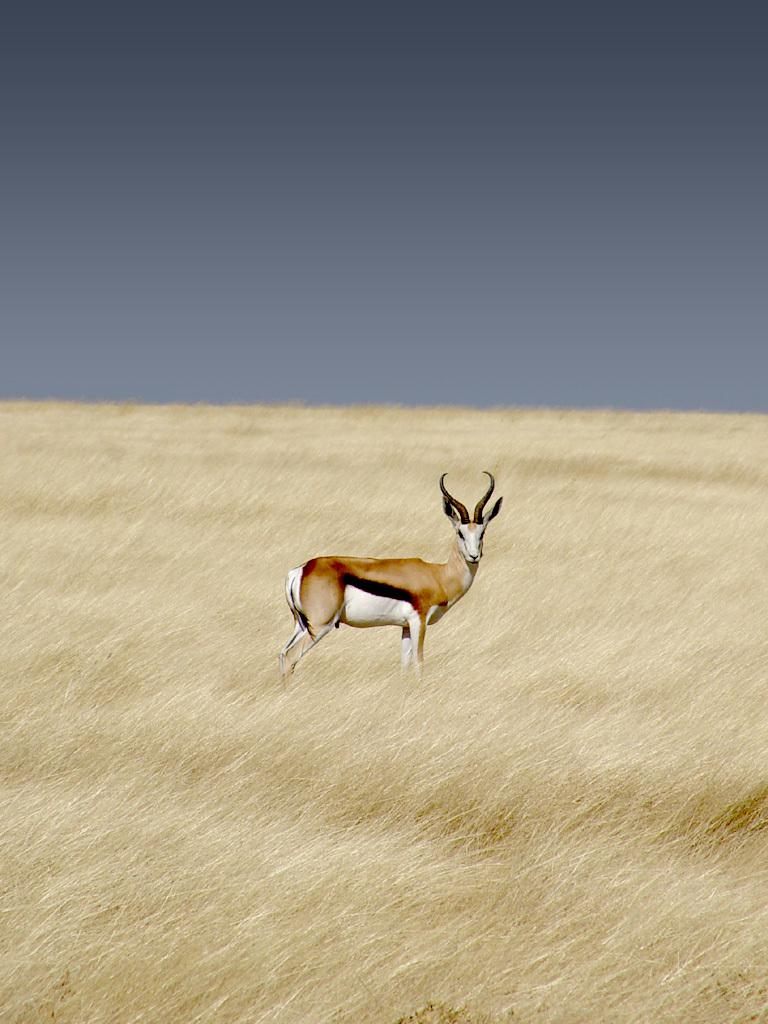What animal is in the center of the image? There is an antelope in the center of the image. What type of vegetation is at the bottom of the image? There is grass at the bottom of the image. What part of the natural environment is visible in the background of the image? The sky is visible in the background of the image. How does the antelope increase its speed in the image? The image does not show the antelope moving or changing its speed, so it cannot be determined from the image. 